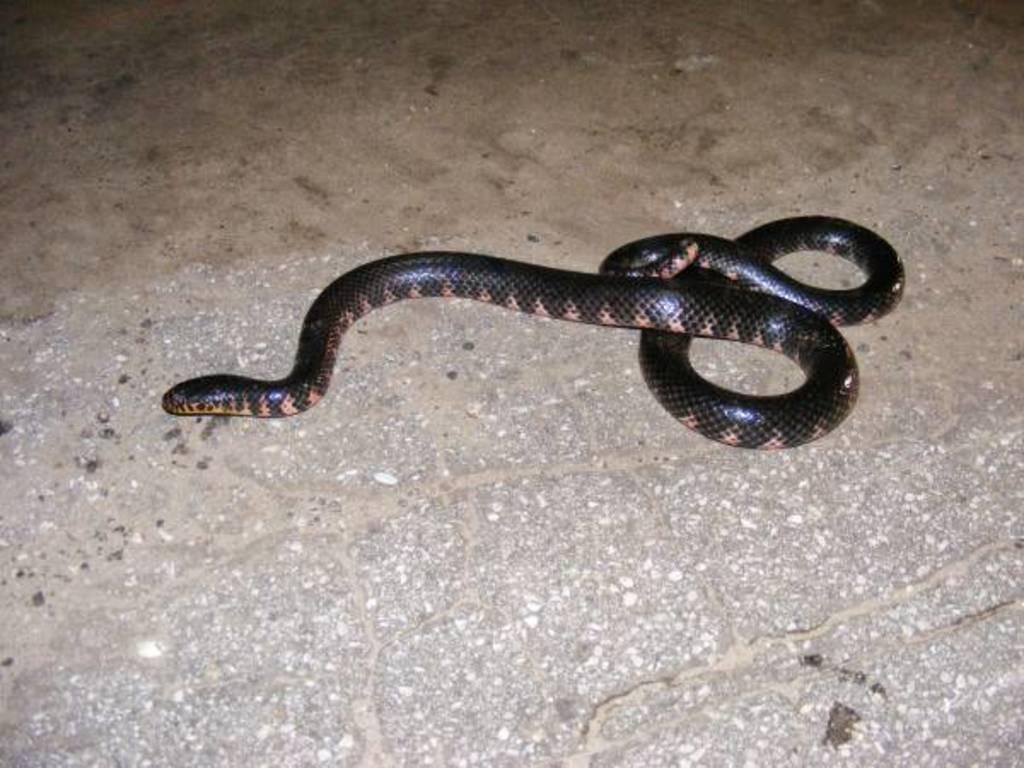What type of animal is present in the image? There is a snake in the image. What type of tin can be seen in the image? There is no tin present in the image; it only features a snake. What is the reason for the snake's presence in the image? The facts provided do not give any information about the reason for the snake's presence in the image. 